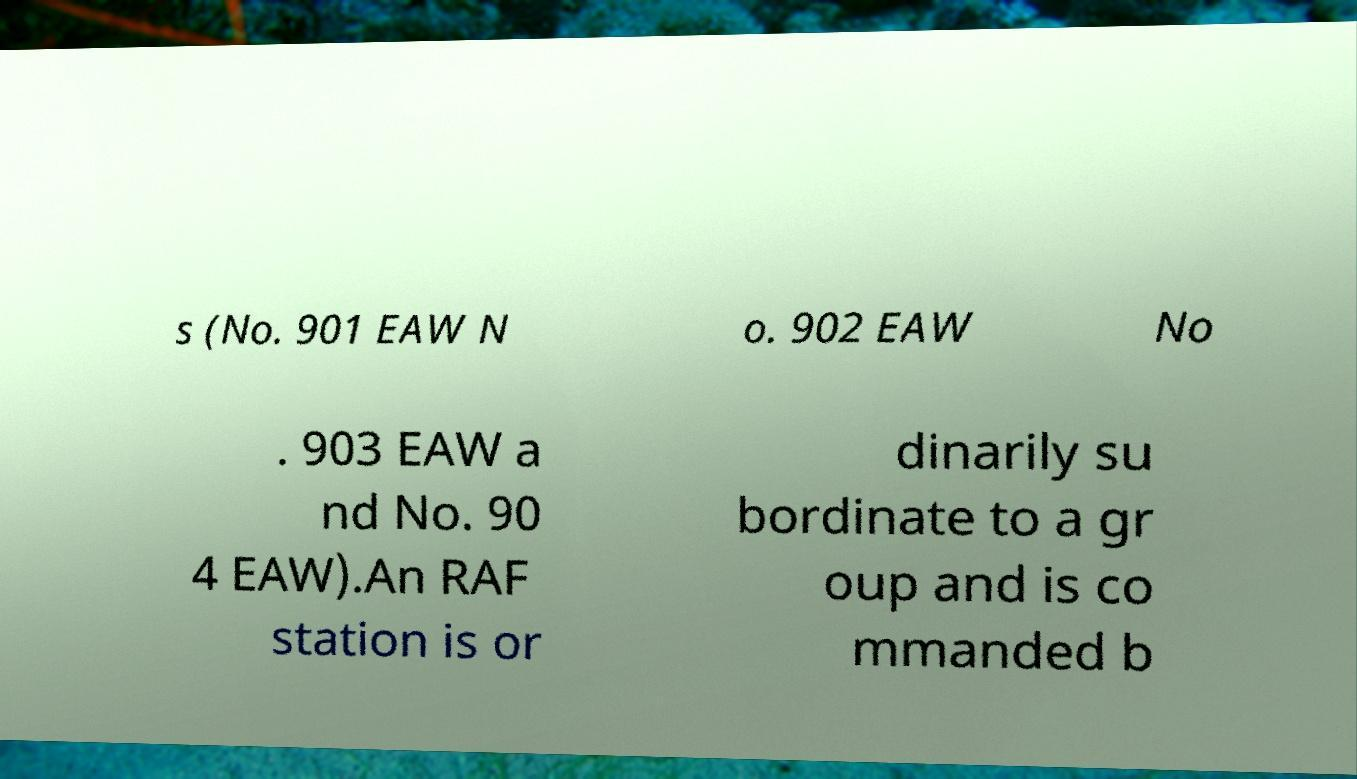I need the written content from this picture converted into text. Can you do that? s (No. 901 EAW N o. 902 EAW No . 903 EAW a nd No. 90 4 EAW).An RAF station is or dinarily su bordinate to a gr oup and is co mmanded b 